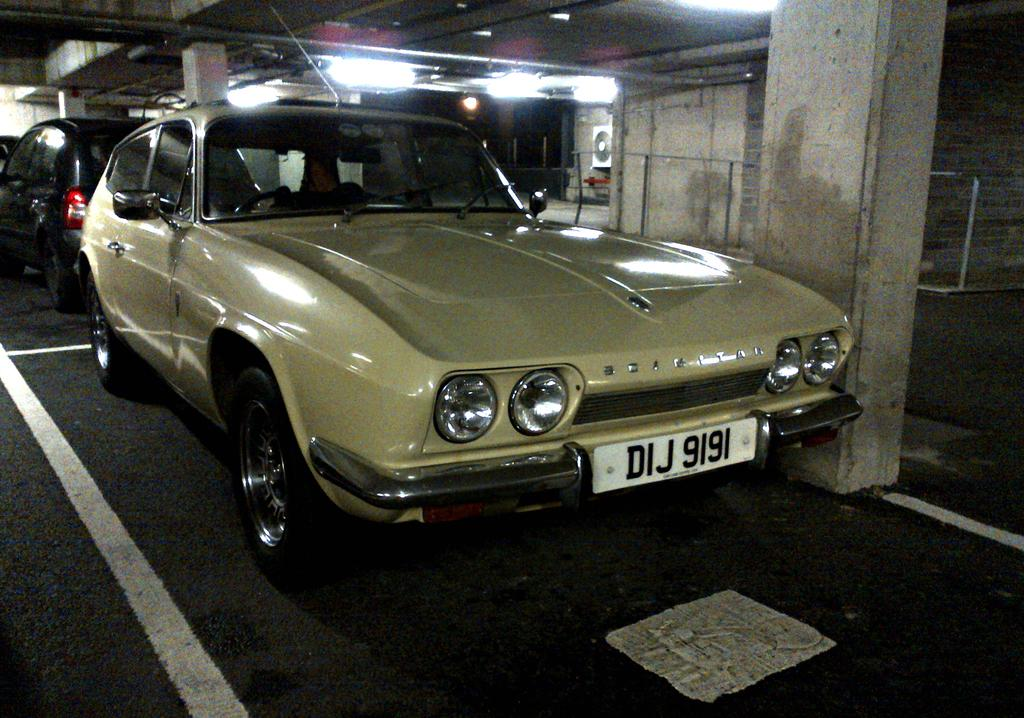What objects are on the floor in the image? There are cars on the floor in the image. What type of architectural features can be seen in the image? There are pillars, railing, and a wall visible in the image. What can be seen in the background of the image? There is a device and lights visible in the background of the image. How many bedrooms are visible in the image? There are no bedrooms visible in the image. What is the reason for the cars being on the floor in the image? The image does not provide any information about the reason for the cars being on the floor. 